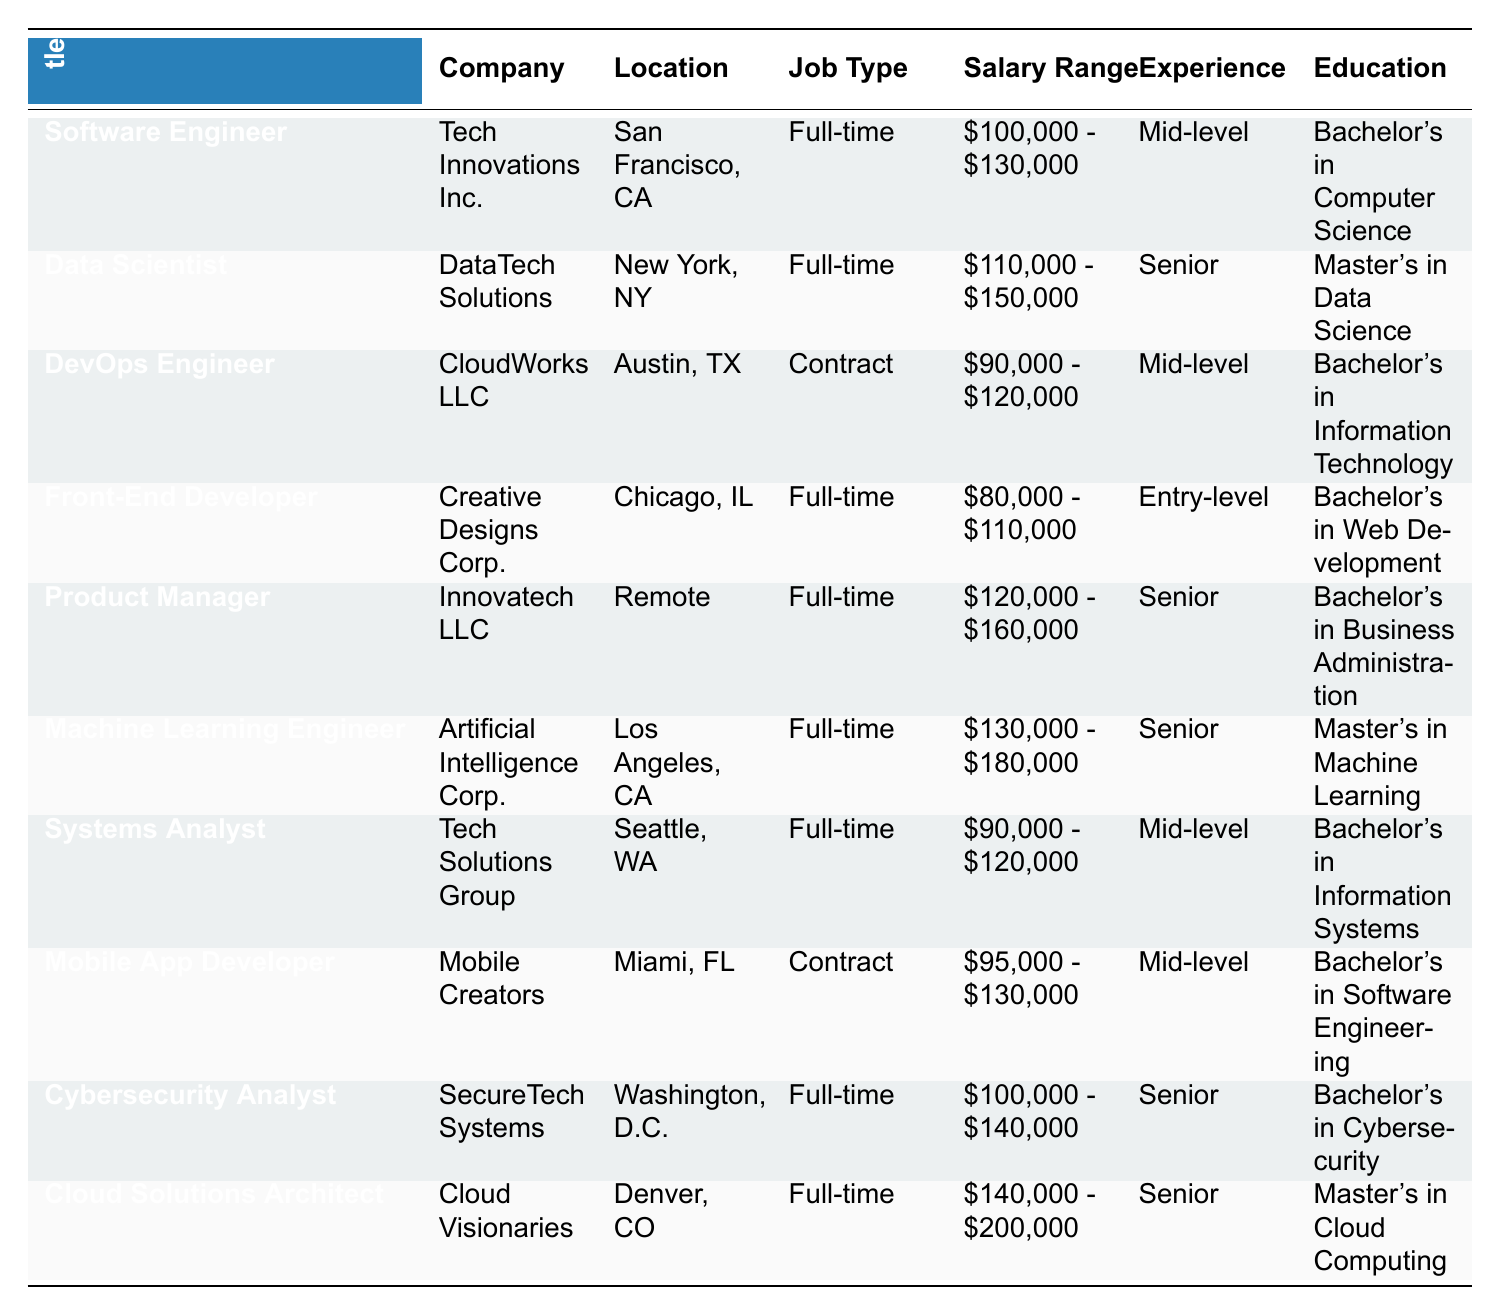What is the highest salary range offered in the job postings? The highest salary range is $140,000 - $200,000 for the "Cloud Solutions Architect" position.
Answer: $140,000 - $200,000 How many positions require a Master's degree? There are three positions that require a Master's degree: Data Scientist, Machine Learning Engineer, and Cloud Solutions Architect.
Answer: 3 Which job type has the most postings? The "Full-time" job type has the most postings, with a total of 6 full-time positions listed.
Answer: Full-time What is the experience level required for the "Cybersecurity Analyst"? The experience level required for the "Cybersecurity Analyst" position is Senior.
Answer: Senior Is there a job posting for an Entry-level position? Yes, there is one job posting for an Entry-level position, which is for the Front-End Developer.
Answer: Yes What is the average salary range for Senior-level positions? The salary ranges for Senior-level positions are $110,000 - $150,000, $130,000 - $180,000, $100,000 - $140,000, and $140,000 - $200,000. Summing these ranges gives 110,000 + 130,000 + 100,000 + 140,000 = 480,000 and 150,000 + 180,000 + 140,000 + 200,000 = 670,000. The average ranges would be $480,000/4 = $120,000 to $670,000/4 = $167,500.
Answer: $120,000 - $167,500 Which company has the highest paid job posting? The company "Cloud Visionaries" has the highest paid job posting for the "Cloud Solutions Architect" position, with a salary range of $140,000 - $200,000.
Answer: Cloud Visionaries What is the posting date for the "DevOps Engineer" position? The posting date for the "DevOps Engineer" position is April 20, 2023.
Answer: April 20, 2023 How many positions are available in remote locations? There is one position available in a remote location, which is for the "Product Manager".
Answer: 1 Which role requires the skill "NLP"? The role that requires the skill "NLP" is the "Machine Learning Engineer".
Answer: Machine Learning Engineer What is the location of the "Data Scientist" job posting? The location of the "Data Scientist" job posting is New York, NY.
Answer: New York, NY 